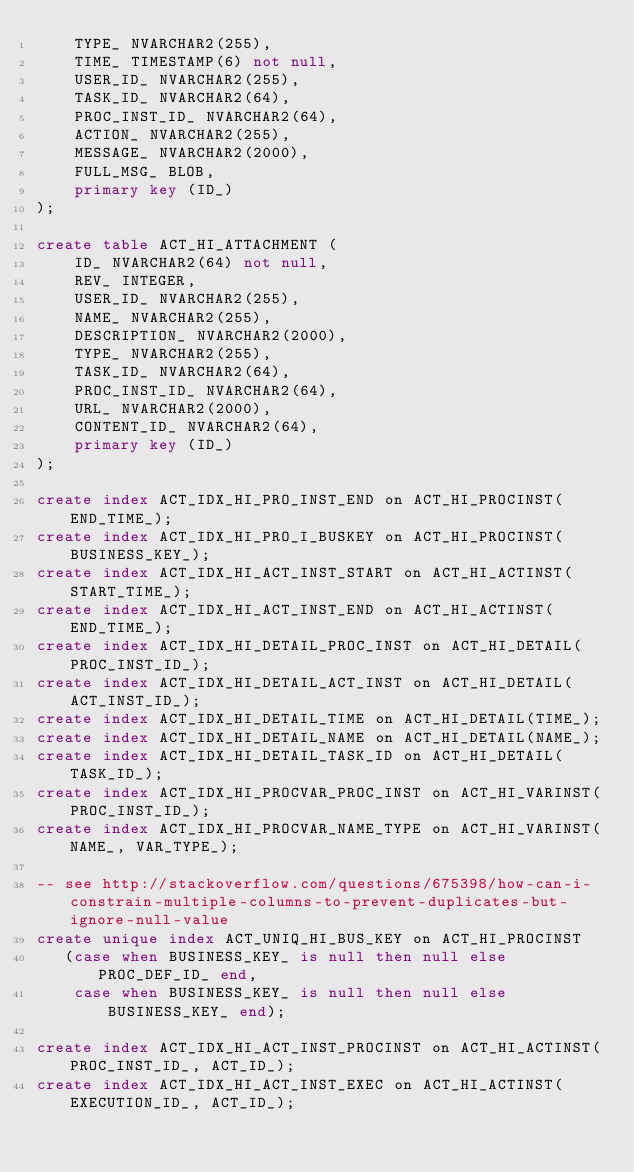Convert code to text. <code><loc_0><loc_0><loc_500><loc_500><_SQL_>    TYPE_ NVARCHAR2(255),
    TIME_ TIMESTAMP(6) not null,
    USER_ID_ NVARCHAR2(255),
    TASK_ID_ NVARCHAR2(64),
    PROC_INST_ID_ NVARCHAR2(64),
    ACTION_ NVARCHAR2(255),
    MESSAGE_ NVARCHAR2(2000),
    FULL_MSG_ BLOB,
    primary key (ID_)
);

create table ACT_HI_ATTACHMENT (
    ID_ NVARCHAR2(64) not null,
    REV_ INTEGER,
    USER_ID_ NVARCHAR2(255),
    NAME_ NVARCHAR2(255),
    DESCRIPTION_ NVARCHAR2(2000),
    TYPE_ NVARCHAR2(255),
    TASK_ID_ NVARCHAR2(64),
    PROC_INST_ID_ NVARCHAR2(64),
    URL_ NVARCHAR2(2000),
    CONTENT_ID_ NVARCHAR2(64),
    primary key (ID_)
);

create index ACT_IDX_HI_PRO_INST_END on ACT_HI_PROCINST(END_TIME_);
create index ACT_IDX_HI_PRO_I_BUSKEY on ACT_HI_PROCINST(BUSINESS_KEY_);
create index ACT_IDX_HI_ACT_INST_START on ACT_HI_ACTINST(START_TIME_);
create index ACT_IDX_HI_ACT_INST_END on ACT_HI_ACTINST(END_TIME_);
create index ACT_IDX_HI_DETAIL_PROC_INST on ACT_HI_DETAIL(PROC_INST_ID_);
create index ACT_IDX_HI_DETAIL_ACT_INST on ACT_HI_DETAIL(ACT_INST_ID_);
create index ACT_IDX_HI_DETAIL_TIME on ACT_HI_DETAIL(TIME_);
create index ACT_IDX_HI_DETAIL_NAME on ACT_HI_DETAIL(NAME_);
create index ACT_IDX_HI_DETAIL_TASK_ID on ACT_HI_DETAIL(TASK_ID_);
create index ACT_IDX_HI_PROCVAR_PROC_INST on ACT_HI_VARINST(PROC_INST_ID_);
create index ACT_IDX_HI_PROCVAR_NAME_TYPE on ACT_HI_VARINST(NAME_, VAR_TYPE_);

-- see http://stackoverflow.com/questions/675398/how-can-i-constrain-multiple-columns-to-prevent-duplicates-but-ignore-null-value
create unique index ACT_UNIQ_HI_BUS_KEY on ACT_HI_PROCINST
   (case when BUSINESS_KEY_ is null then null else PROC_DEF_ID_ end,
    case when BUSINESS_KEY_ is null then null else BUSINESS_KEY_ end);

create index ACT_IDX_HI_ACT_INST_PROCINST on ACT_HI_ACTINST(PROC_INST_ID_, ACT_ID_);
create index ACT_IDX_HI_ACT_INST_EXEC on ACT_HI_ACTINST(EXECUTION_ID_, ACT_ID_);
</code> 